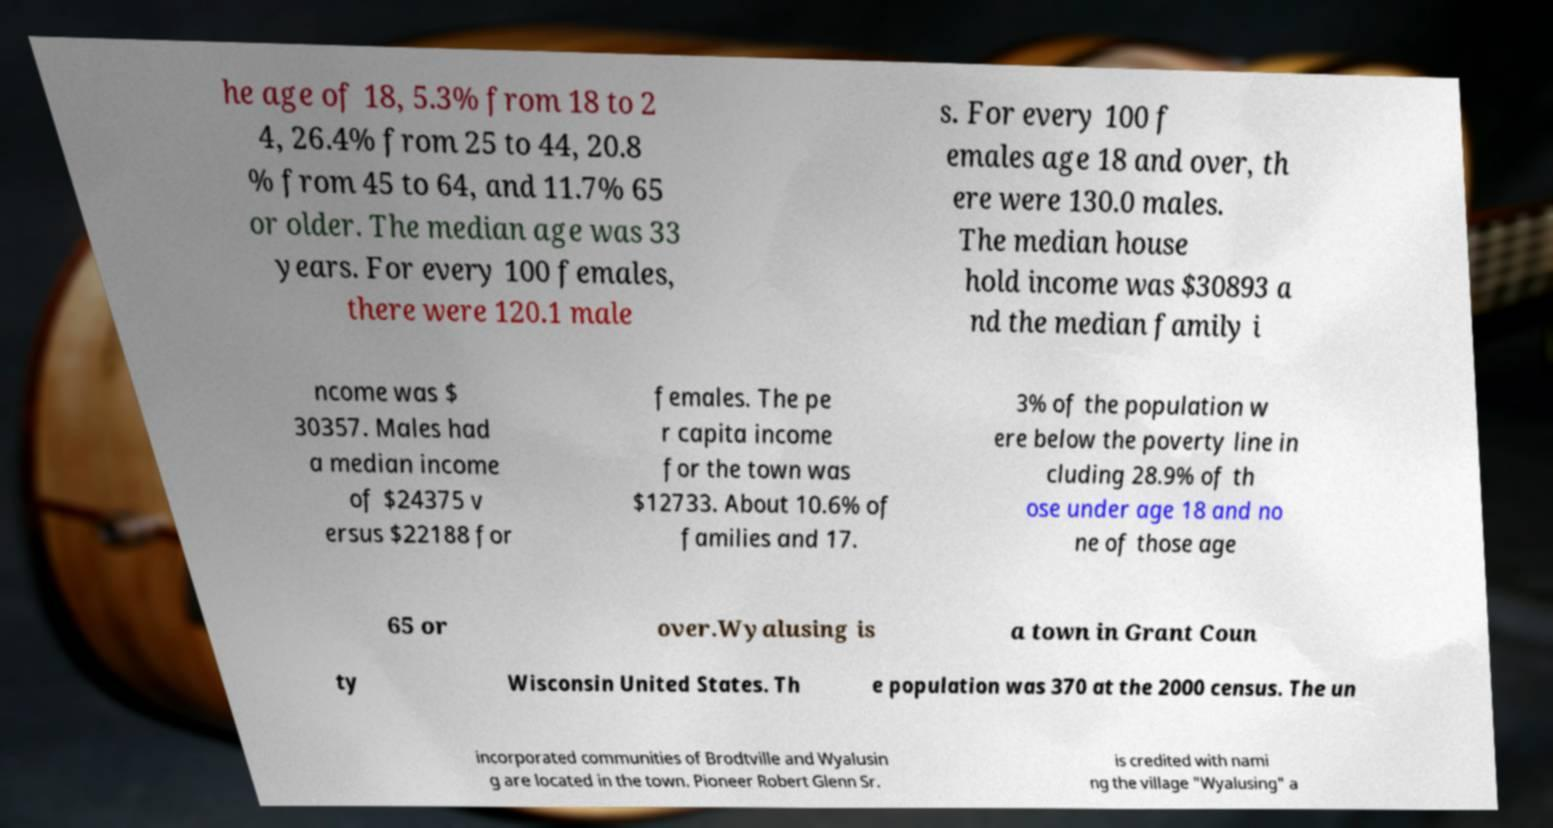For documentation purposes, I need the text within this image transcribed. Could you provide that? he age of 18, 5.3% from 18 to 2 4, 26.4% from 25 to 44, 20.8 % from 45 to 64, and 11.7% 65 or older. The median age was 33 years. For every 100 females, there were 120.1 male s. For every 100 f emales age 18 and over, th ere were 130.0 males. The median house hold income was $30893 a nd the median family i ncome was $ 30357. Males had a median income of $24375 v ersus $22188 for females. The pe r capita income for the town was $12733. About 10.6% of families and 17. 3% of the population w ere below the poverty line in cluding 28.9% of th ose under age 18 and no ne of those age 65 or over.Wyalusing is a town in Grant Coun ty Wisconsin United States. Th e population was 370 at the 2000 census. The un incorporated communities of Brodtville and Wyalusin g are located in the town. Pioneer Robert Glenn Sr. is credited with nami ng the village "Wyalusing" a 